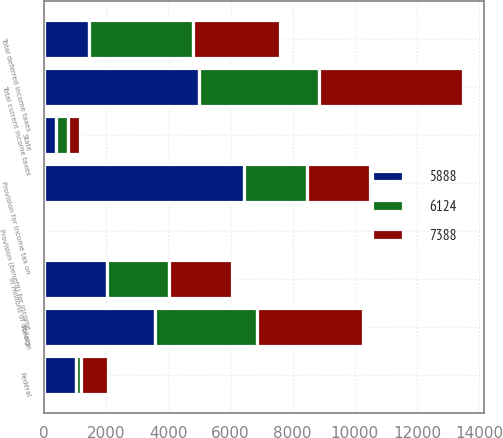<chart> <loc_0><loc_0><loc_500><loc_500><stacked_bar_chart><ecel><fcel>In millions of dollars<fcel>Federal<fcel>Foreign<fcel>State<fcel>Total current income taxes<fcel>Total deferred income taxes<fcel>Provision for income tax on<fcel>Provision (benefit) for income<nl><fcel>5888<fcel>2016<fcel>1016<fcel>3585<fcel>384<fcel>4985<fcel>1459<fcel>6444<fcel>22<nl><fcel>7388<fcel>2015<fcel>861<fcel>3397<fcel>388<fcel>4646<fcel>2794<fcel>2014.5<fcel>29<nl><fcel>6124<fcel>2014<fcel>181<fcel>3281<fcel>388<fcel>3850<fcel>3347<fcel>2014.5<fcel>12<nl></chart> 